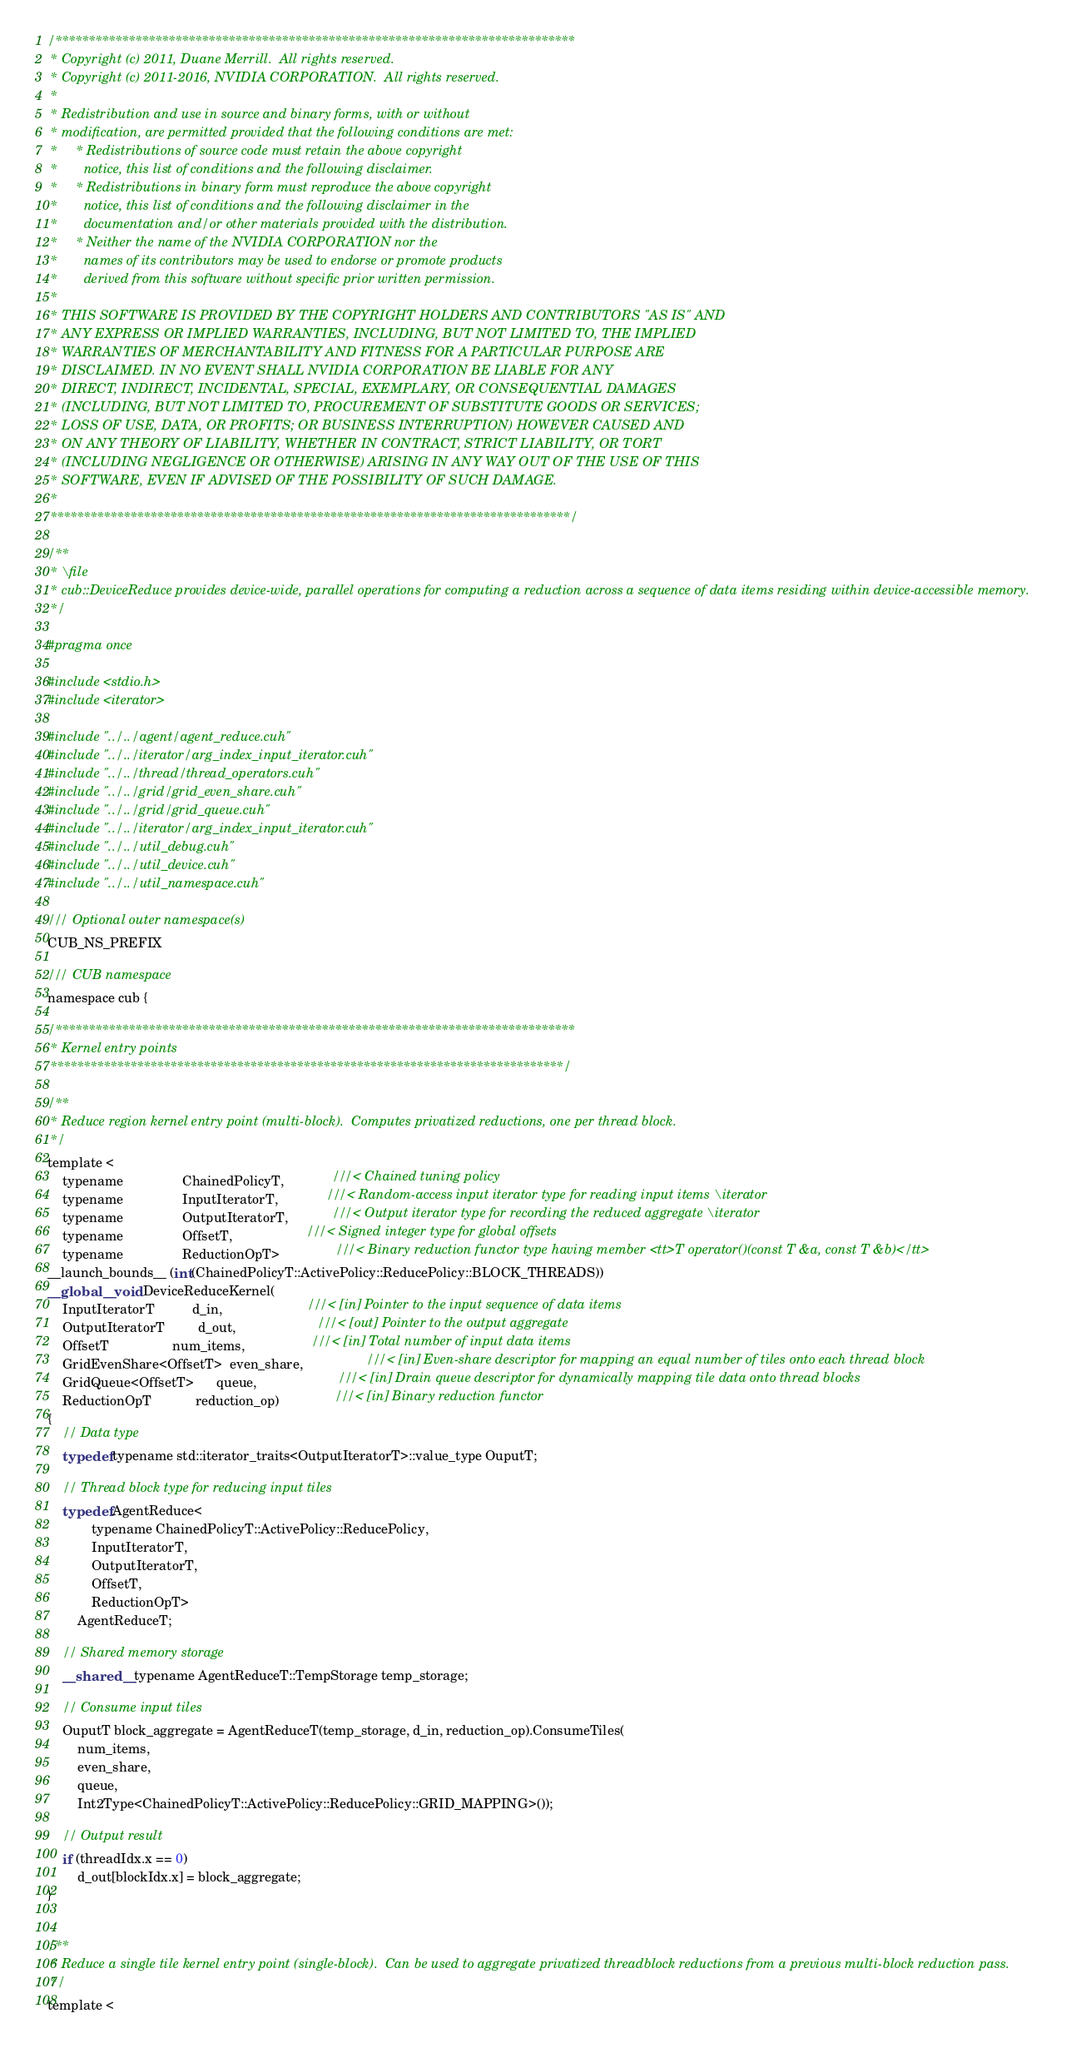<code> <loc_0><loc_0><loc_500><loc_500><_Cuda_>
/******************************************************************************
 * Copyright (c) 2011, Duane Merrill.  All rights reserved.
 * Copyright (c) 2011-2016, NVIDIA CORPORATION.  All rights reserved.
 *
 * Redistribution and use in source and binary forms, with or without
 * modification, are permitted provided that the following conditions are met:
 *     * Redistributions of source code must retain the above copyright
 *       notice, this list of conditions and the following disclaimer.
 *     * Redistributions in binary form must reproduce the above copyright
 *       notice, this list of conditions and the following disclaimer in the
 *       documentation and/or other materials provided with the distribution.
 *     * Neither the name of the NVIDIA CORPORATION nor the
 *       names of its contributors may be used to endorse or promote products
 *       derived from this software without specific prior written permission.
 *
 * THIS SOFTWARE IS PROVIDED BY THE COPYRIGHT HOLDERS AND CONTRIBUTORS "AS IS" AND
 * ANY EXPRESS OR IMPLIED WARRANTIES, INCLUDING, BUT NOT LIMITED TO, THE IMPLIED
 * WARRANTIES OF MERCHANTABILITY AND FITNESS FOR A PARTICULAR PURPOSE ARE
 * DISCLAIMED. IN NO EVENT SHALL NVIDIA CORPORATION BE LIABLE FOR ANY
 * DIRECT, INDIRECT, INCIDENTAL, SPECIAL, EXEMPLARY, OR CONSEQUENTIAL DAMAGES
 * (INCLUDING, BUT NOT LIMITED TO, PROCUREMENT OF SUBSTITUTE GOODS OR SERVICES;
 * LOSS OF USE, DATA, OR PROFITS; OR BUSINESS INTERRUPTION) HOWEVER CAUSED AND
 * ON ANY THEORY OF LIABILITY, WHETHER IN CONTRACT, STRICT LIABILITY, OR TORT
 * (INCLUDING NEGLIGENCE OR OTHERWISE) ARISING IN ANY WAY OUT OF THE USE OF THIS
 * SOFTWARE, EVEN IF ADVISED OF THE POSSIBILITY OF SUCH DAMAGE.
 *
 ******************************************************************************/

/**
 * \file
 * cub::DeviceReduce provides device-wide, parallel operations for computing a reduction across a sequence of data items residing within device-accessible memory.
 */

#pragma once

#include <stdio.h>
#include <iterator>

#include "../../agent/agent_reduce.cuh"
#include "../../iterator/arg_index_input_iterator.cuh"
#include "../../thread/thread_operators.cuh"
#include "../../grid/grid_even_share.cuh"
#include "../../grid/grid_queue.cuh"
#include "../../iterator/arg_index_input_iterator.cuh"
#include "../../util_debug.cuh"
#include "../../util_device.cuh"
#include "../../util_namespace.cuh"

/// Optional outer namespace(s)
CUB_NS_PREFIX

/// CUB namespace
namespace cub {

/******************************************************************************
 * Kernel entry points
 *****************************************************************************/

/**
 * Reduce region kernel entry point (multi-block).  Computes privatized reductions, one per thread block.
 */
template <
    typename                ChainedPolicyT,             ///< Chained tuning policy
    typename                InputIteratorT,             ///< Random-access input iterator type for reading input items \iterator
    typename                OutputIteratorT,            ///< Output iterator type for recording the reduced aggregate \iterator
    typename                OffsetT,                    ///< Signed integer type for global offsets
    typename                ReductionOpT>               ///< Binary reduction functor type having member <tt>T operator()(const T &a, const T &b)</tt>
__launch_bounds__ (int(ChainedPolicyT::ActivePolicy::ReducePolicy::BLOCK_THREADS))
__global__ void DeviceReduceKernel(
    InputIteratorT          d_in,                       ///< [in] Pointer to the input sequence of data items
    OutputIteratorT         d_out,                      ///< [out] Pointer to the output aggregate
    OffsetT                 num_items,                  ///< [in] Total number of input data items
    GridEvenShare<OffsetT>  even_share,                 ///< [in] Even-share descriptor for mapping an equal number of tiles onto each thread block
    GridQueue<OffsetT>      queue,                      ///< [in] Drain queue descriptor for dynamically mapping tile data onto thread blocks
    ReductionOpT            reduction_op)               ///< [in] Binary reduction functor
{
    // Data type
    typedef typename std::iterator_traits<OutputIteratorT>::value_type OuputT;

    // Thread block type for reducing input tiles
    typedef AgentReduce<
            typename ChainedPolicyT::ActivePolicy::ReducePolicy,
            InputIteratorT,
            OutputIteratorT,
            OffsetT,
            ReductionOpT>
        AgentReduceT;

    // Shared memory storage
    __shared__ typename AgentReduceT::TempStorage temp_storage;

    // Consume input tiles
    OuputT block_aggregate = AgentReduceT(temp_storage, d_in, reduction_op).ConsumeTiles(
        num_items,
        even_share,
        queue,
        Int2Type<ChainedPolicyT::ActivePolicy::ReducePolicy::GRID_MAPPING>());

    // Output result
    if (threadIdx.x == 0)
        d_out[blockIdx.x] = block_aggregate;
}


/**
 * Reduce a single tile kernel entry point (single-block).  Can be used to aggregate privatized threadblock reductions from a previous multi-block reduction pass.
 */
template <</code> 